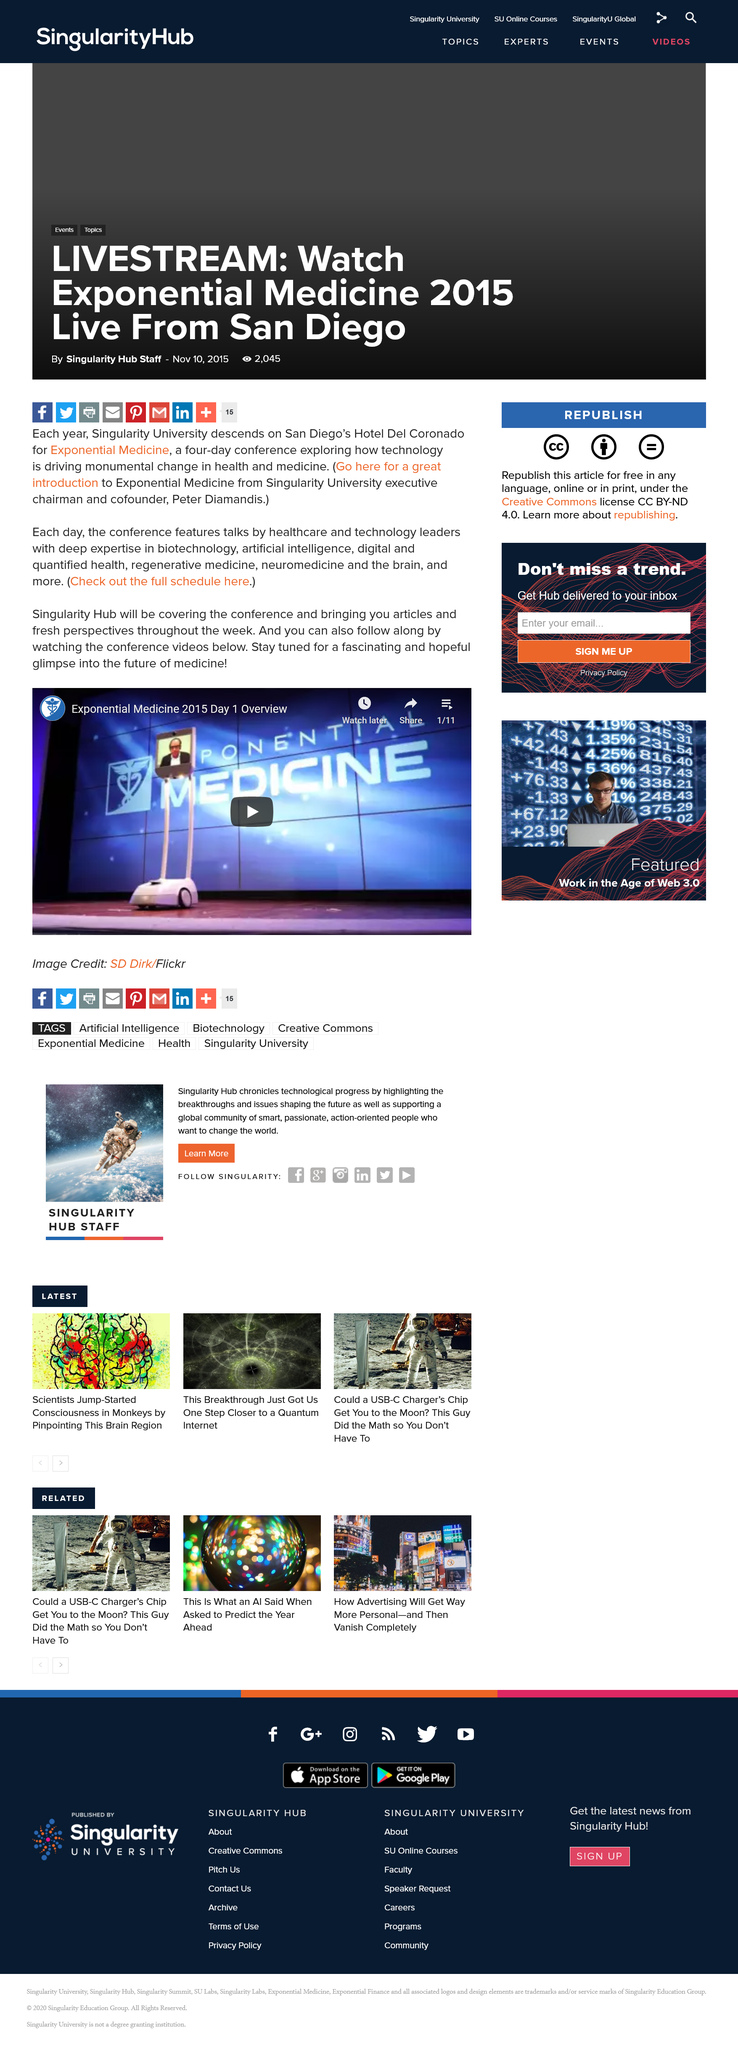Mention a couple of crucial points in this snapshot. The Exponential Medicine Conference is held annually in San Diego at the Hotel Del Coronado. The Exponential Medicine Conference will explore how technology is driving monumental changes in health and medicine, and will delve into the various ways in which this is happening. The Exponential Medicine Conference lasts for four days. 